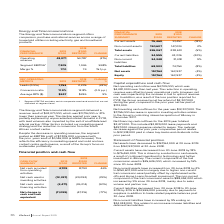According to Iselect's financial document, What is the percentage change in the net cash provided from operating activities? According to the financial document, 46%. The relevant text states: "Segment EBITDA 1 7,305 1,046 598%..." Also, What is the percentage change in the net cash provided from investing activities? According to the financial document, (39%). The relevant text states: "ash used in investing activities (12,337) (20,092) (39%)..." Also, What is the percentage change in the net cash provided from financing activities? According to the financial document, (90%). The relevant text states: "cash used in financing activities (3,471) (36,014) (90%)..." Also, can you calculate: What is the change in the net cash provided from operating activities from 2018 to 2019? Based on the calculation: 4,709-8,790, the result is -4081 (in thousands). This is based on the information: "4,709 8,790 46% 4,709 8,790 46%..." The key data points involved are: 4,709, 8,790. Also, can you calculate: What is the change in Net cash used in financing activities from 2018 to 2019? Based on the calculation: (3,471)-(36,014), the result is 32543 (in thousands). This is based on the information: "Net cash used in financing activities (3,471) (36,014) (90%) Net cash used in financing activities (3,471) (36,014) (90%)..." The key data points involved are: 3,471, 36,014. Also, can you calculate: What is the change in Net change in cash and cash equivalent from 2018 to 2019? Based on the calculation: (11,099)-(47,316), the result is 36217 (in thousands). This is based on the information: "(11,099) (47,316) (77%) (11,099) (47,316) (77%)..." The key data points involved are: 11,099, 47,316. 